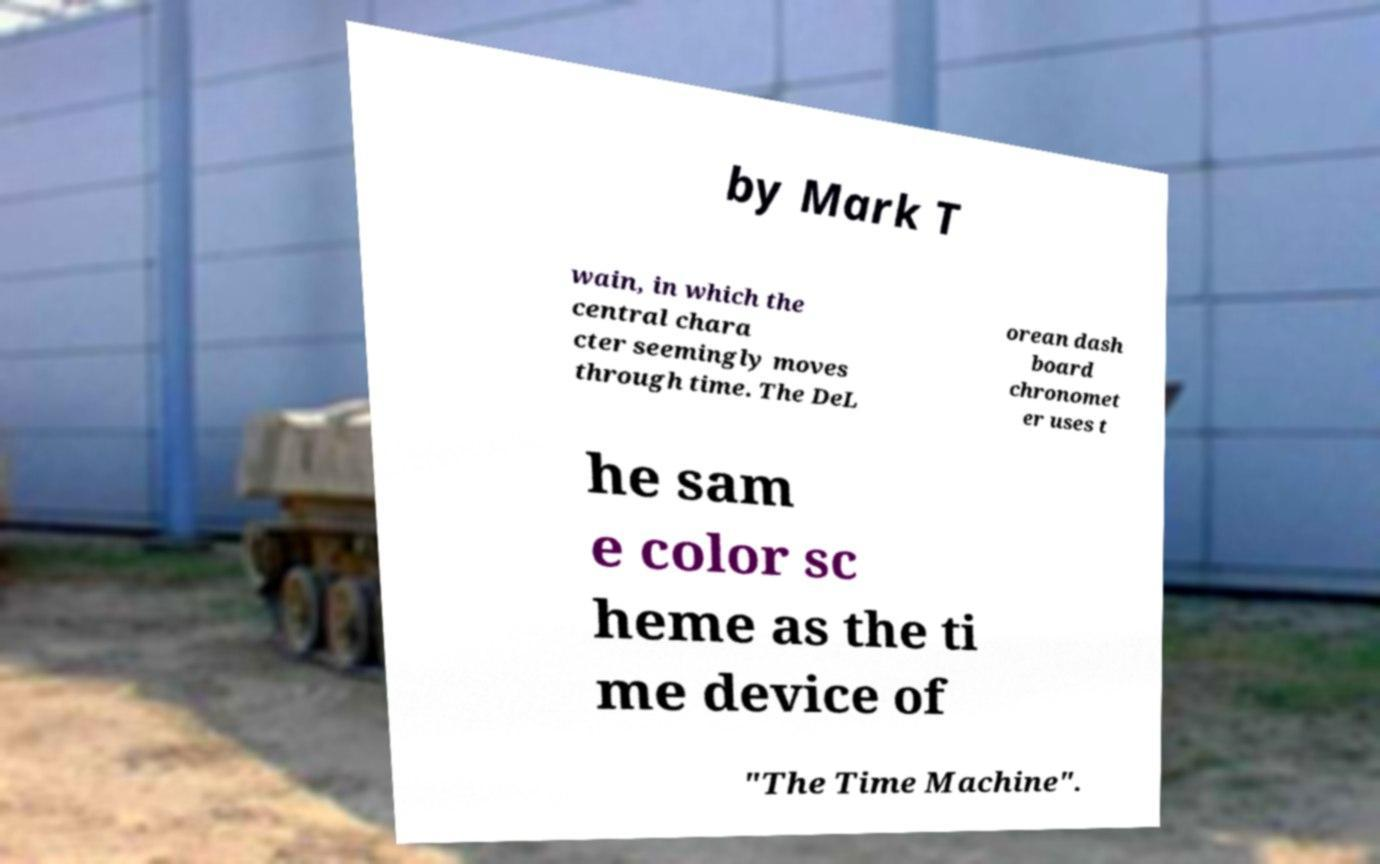I need the written content from this picture converted into text. Can you do that? by Mark T wain, in which the central chara cter seemingly moves through time. The DeL orean dash board chronomet er uses t he sam e color sc heme as the ti me device of "The Time Machine". 